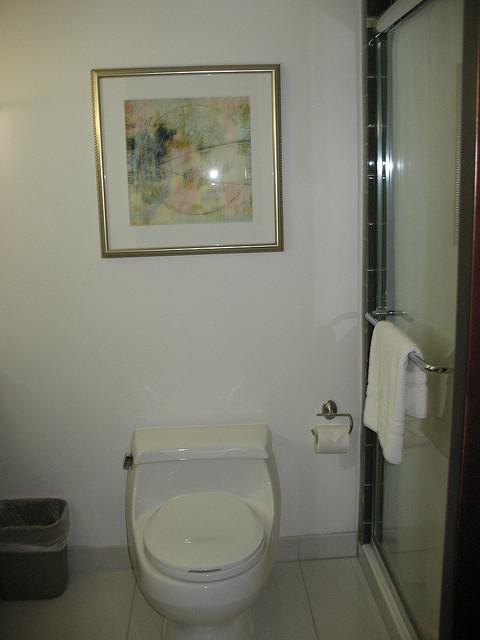Is there a window in this picture?
Quick response, please. No. Is this a narrow bathroom?
Quick response, please. Yes. Is the toilet clean?
Answer briefly. Yes. Is the toilet seat open?
Be succinct. No. Is there a hose extension coming from the water pipe?
Concise answer only. No. Can you see through the shower?
Keep it brief. Yes. What is above the toilet?
Give a very brief answer. Picture. How would you describe the conditions of the bathroom?
Short answer required. Clean. What color are walls painted?
Short answer required. White. How many folded towels do count?
Answer briefly. 1. Is the toilet seat closed?
Write a very short answer. Yes. Is the toilet seat up?
Short answer required. No. What is the picture of above the toilet?
Concise answer only. Abstract. Where is the towel?
Answer briefly. Door. What number of towels are on the towel rack?
Concise answer only. 1. Is the floor wood?
Be succinct. No. How many towels are there?
Write a very short answer. 1. Is there a jar candle on top of the toilet?
Concise answer only. No. How many mirrors are shown?
Be succinct. 0. Does the shower have glass doors?
Be succinct. Yes. What is the floor made of?
Short answer required. Tile. Is the toilet seat down?
Give a very brief answer. Yes. How many hand towels are in this bathroom?
Give a very brief answer. 1. Is the bathroom dirty?
Quick response, please. No. Is there a mirror on the wall?
Be succinct. No. What is the purpose of the cloth folded at the shower?
Keep it brief. Towel. Does the trash need to be taken out?
Keep it brief. No. Is this room spacious?
Concise answer only. No. Is this a public toilet?
Be succinct. No. What is on the wall next to the toilet?
Short answer required. Toilet paper. What large geometric shape is on the back wall?
Keep it brief. Square. Do the walls need to be repainted?
Quick response, please. No. What is hanging on the wall?
Write a very short answer. Picture. What kind of room would this be called?
Short answer required. Bathroom. How many rolls of toilet paper are there?
Quick response, please. 1. What color is the wall?
Write a very short answer. White. Is the bathroom clean?
Be succinct. Yes. What color is the towel?
Quick response, please. White. What is the door made of?
Give a very brief answer. Glass. Is there a toilet cleaning item in the picture?
Quick response, please. No. Why is there a bar next to the toilet?
Write a very short answer. No. What is behind the toilet?
Write a very short answer. Picture. What color is the towel that is hanging?
Write a very short answer. White. How many towels are pictured?
Give a very brief answer. 1. Why is there a seat on the toilet bowl?
Short answer required. To sit on. How many places are reflecting the flash?
Keep it brief. 2. Is there a bathroom sink?
Concise answer only. No. What color is the trash can?
Answer briefly. Gray. How many towels are in the room?
Short answer required. 1. Is there any toilet paper?
Answer briefly. Yes. 